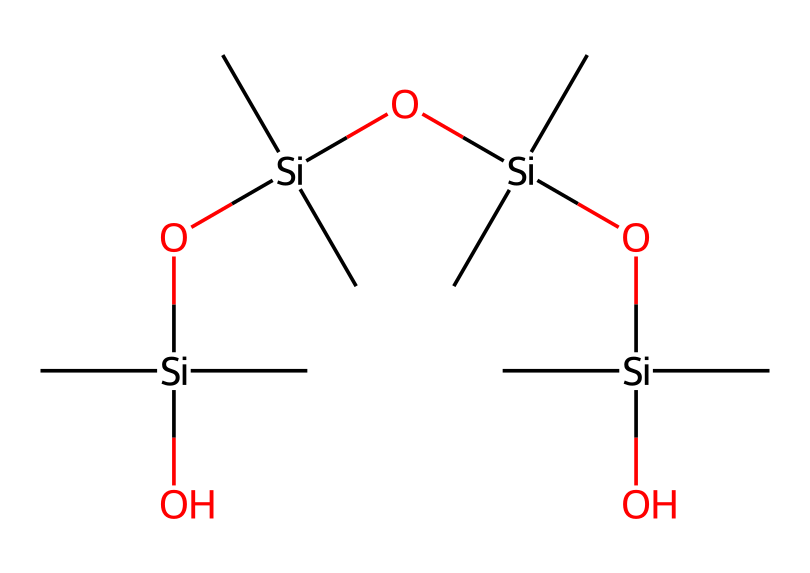What is the primary element present in this lubricant? The chemical structure prominently features silicon, which is represented by the “Si” symbol at the beginning of the SMILES. Thus, the primary element in this silicone-based lubricant is silicon.
Answer: silicon How many oxygen atoms are in this chemical structure? By analyzing the SMILES, we can count the number of times the symbol "O" appears. There are four oxygen atoms present in the structure as indicated in the SMILES representation.
Answer: four What type of bonding predominates in this lubricant? The presence of silicon-oxygen bonds makes covalent bonding the primary type of bonding in this chemical. The overall structure shows multiple Si-O and Si-C connections, further confirming a covalent nature.
Answer: covalent What is the average degree of branching for this chemical? In the SMILES, each silicon atom is directly connected to two carbon atoms and has a branching point leading towards oxygen atoms. With multiple silicon atoms connected in a linear fashion, the branching degree can be calculated as high due to the multiple interconnected siloxane units.
Answer: high How many silicon atoms are present in this lubricating compound? The SMILES structure indicates the number of silicon atoms by looking at each “Si”. In this specific SMILES, there are five silicon atoms present due to the repeating pattern of "Si" throughout the compound.
Answer: five What functional groups are present in this chemical? The chemical features hydroxyl (Si-OH) and siloxane (Si-O-Si) functional groups, which are key characteristics of silicone-based lubricants. This is deduced from the presence of silicon atoms bound to oxygen, as well as the terminal hydroxyl groups.
Answer: hydroxyl and siloxane 